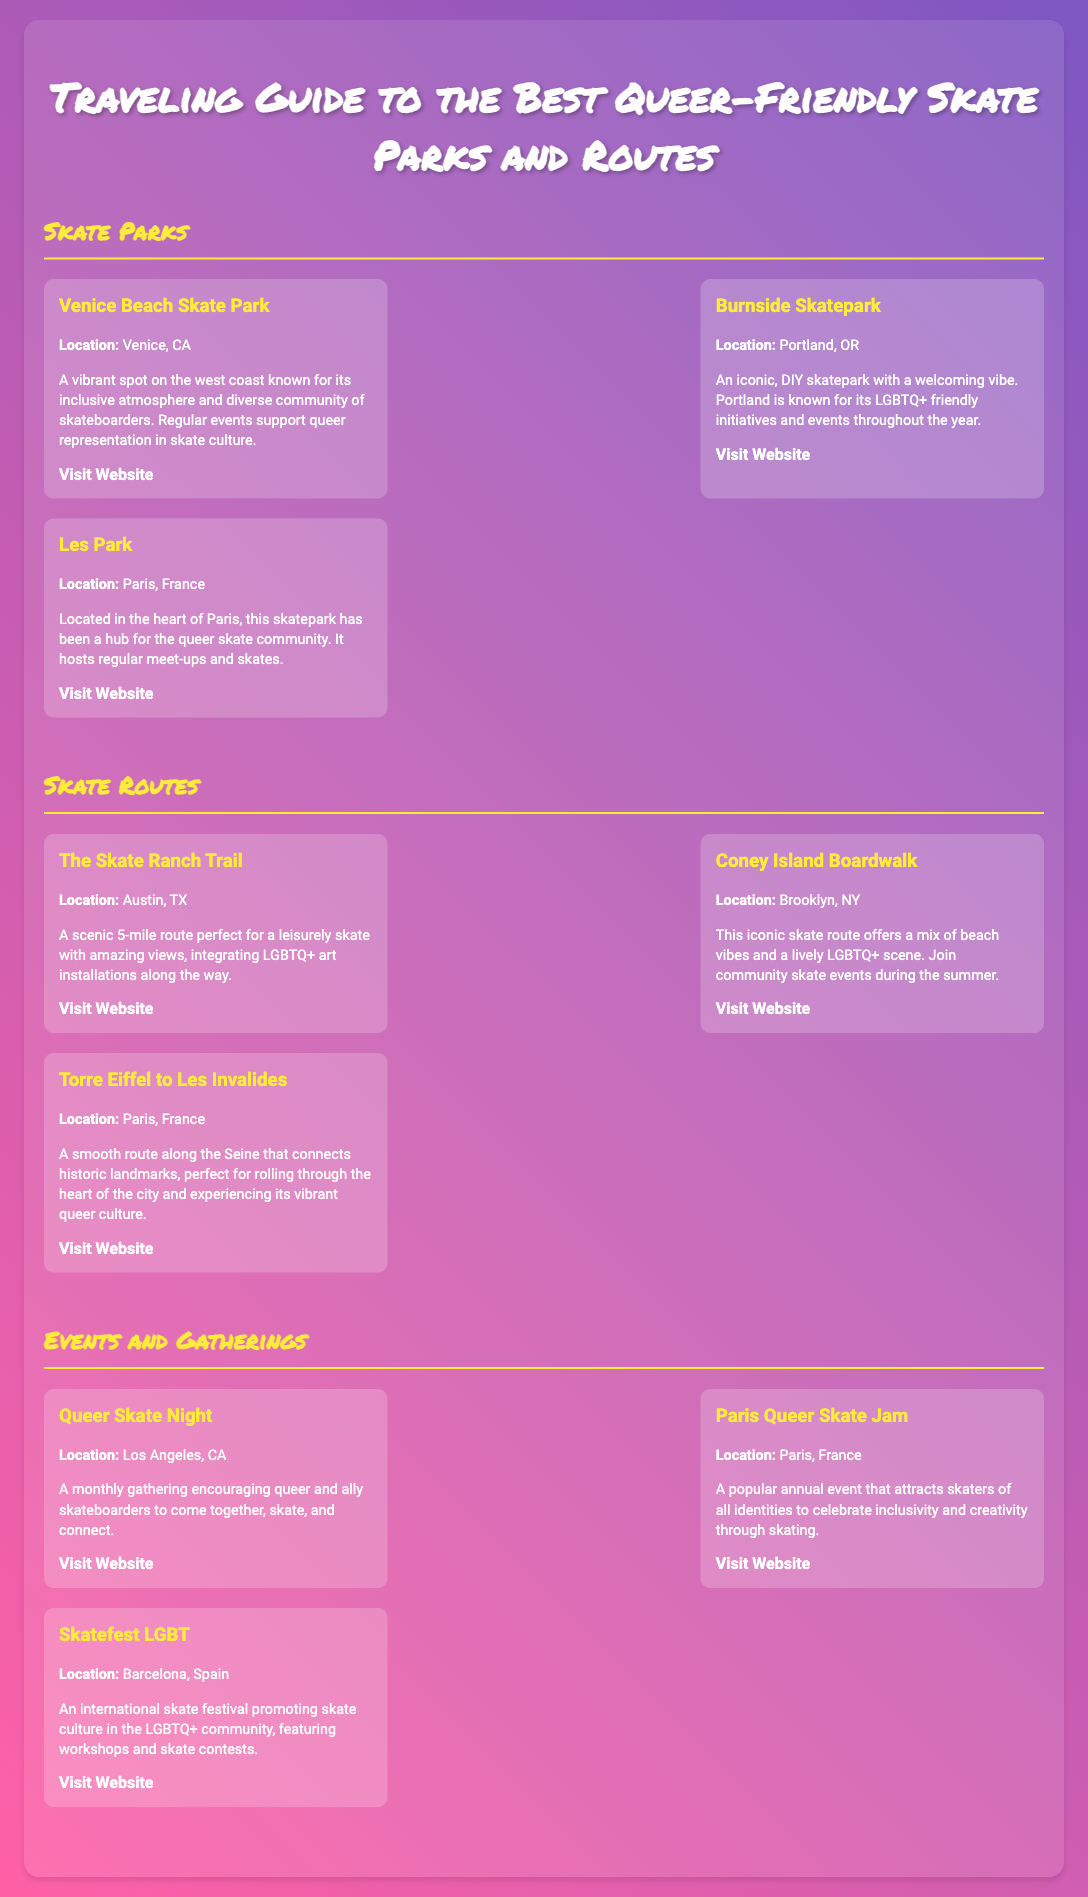what event is held in Los Angeles, CA? The document mentions specific events that take place in various locations, detailing one in Los Angeles.
Answer: Queer Skate Night what is the title of the event in Paris, France? The title of the event is mentioned as one of the highlighted gatherings.
Answer: Paris Queer Skate Jam which skate route is located in Brooklyn, NY? The document lists skate routes along with their locations; Brooklyn NY route is specified.
Answer: Coney Island Boardwalk which skatepark is known for its DIY structure? The document describes skate parks with specific attributes, including a DIY structure referred to explicitly.
Answer: Burnside Skatepark which city features the skate route from Torre Eiffel to Les Invalides? The document lists the locations for different skate routes, specifying one related to Paris.
Answer: Paris, France how often does the Queer Skate Night occur? The document specifies the frequency of the events mentioned under "Events and Gatherings."
Answer: Monthly 